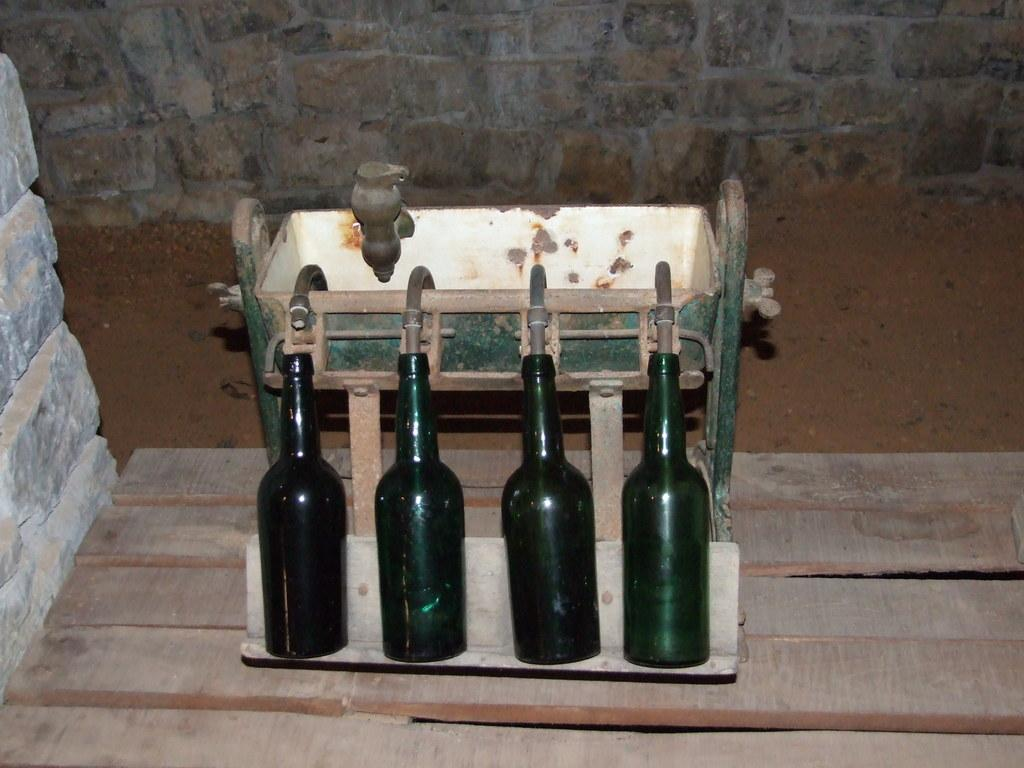How many bottles are in the image? There are four bottles in the image. What are the bottles connected to? The bottles are connected to pipes. What is the purpose of the pipes? The pipes are part of a machine. Where is the machine located? The machine is on a table. What type of background can be seen in the image? There is a stone wall and sand visible in the image. What type of grape is being used to write on the sand in the image? There is no grape present in the image, and grapes are not used for writing. 